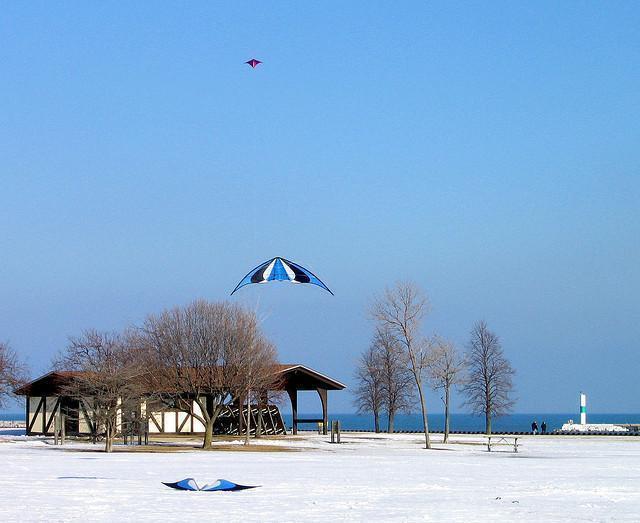The kites perform was motion in order to move across the sky?
Make your selection and explain in format: 'Answer: answer
Rationale: rationale.'
Options: They jump, they skip, they glide, they catch. Answer: they glide.
Rationale: The wind lifts the material in a smooth motion. 